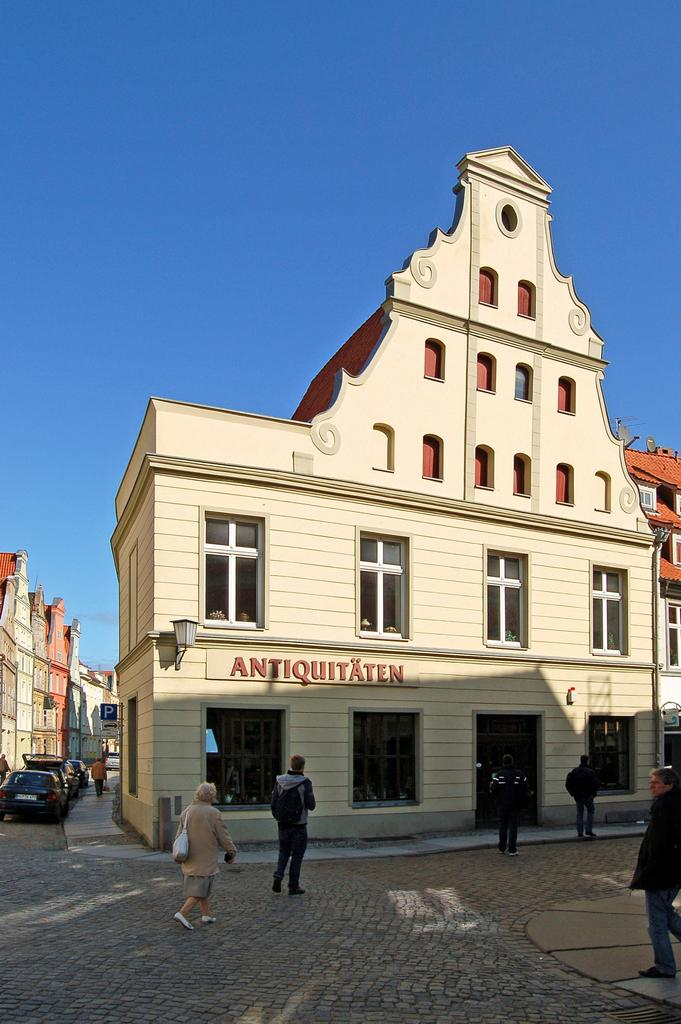<image>
Give a short and clear explanation of the subsequent image. a white building with red lettering on the side of it that says 'antiquitaten' 